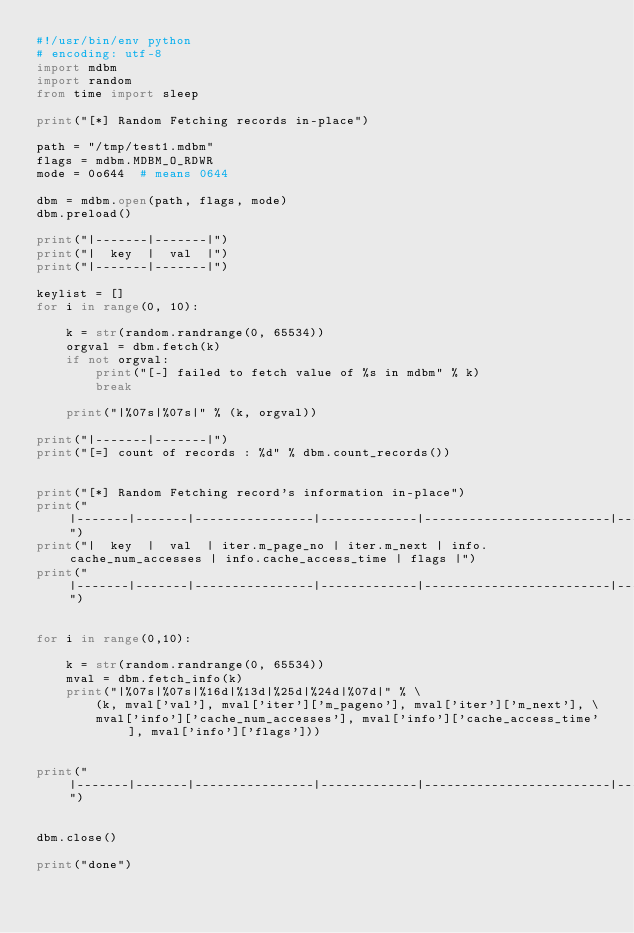Convert code to text. <code><loc_0><loc_0><loc_500><loc_500><_Python_>#!/usr/bin/env python
# encoding: utf-8
import mdbm
import random
from time import sleep

print("[*] Random Fetching records in-place")

path = "/tmp/test1.mdbm"
flags = mdbm.MDBM_O_RDWR
mode = 0o644  # means 0644

dbm = mdbm.open(path, flags, mode)
dbm.preload()

print("|-------|-------|")
print("|  key  |  val  |")
print("|-------|-------|")

keylist = []
for i in range(0, 10):

    k = str(random.randrange(0, 65534))
    orgval = dbm.fetch(k)
    if not orgval:
        print("[-] failed to fetch value of %s in mdbm" % k)
        break

    print("|%07s|%07s|" % (k, orgval))

print("|-------|-------|")
print("[=] count of records : %d" % dbm.count_records())


print("[*] Random Fetching record's information in-place")
print("|-------|-------|----------------|-------------|-------------------------|------------------------|-------|")
print("|  key  |  val  | iter.m_page_no | iter.m_next | info.cache_num_accesses | info.cache_access_time | flags |")
print("|-------|-------|----------------|-------------|-------------------------|------------------------|-------|")


for i in range(0,10):

    k = str(random.randrange(0, 65534))
    mval = dbm.fetch_info(k)
    print("|%07s|%07s|%16d|%13d|%25d|%24d|%07d|" % \
        (k, mval['val'], mval['iter']['m_pageno'], mval['iter']['m_next'], \
        mval['info']['cache_num_accesses'], mval['info']['cache_access_time'], mval['info']['flags']))


print("|-------|-------|----------------|-------------|-------------------------|------------------------|-------|")


dbm.close()

print("done")
</code> 